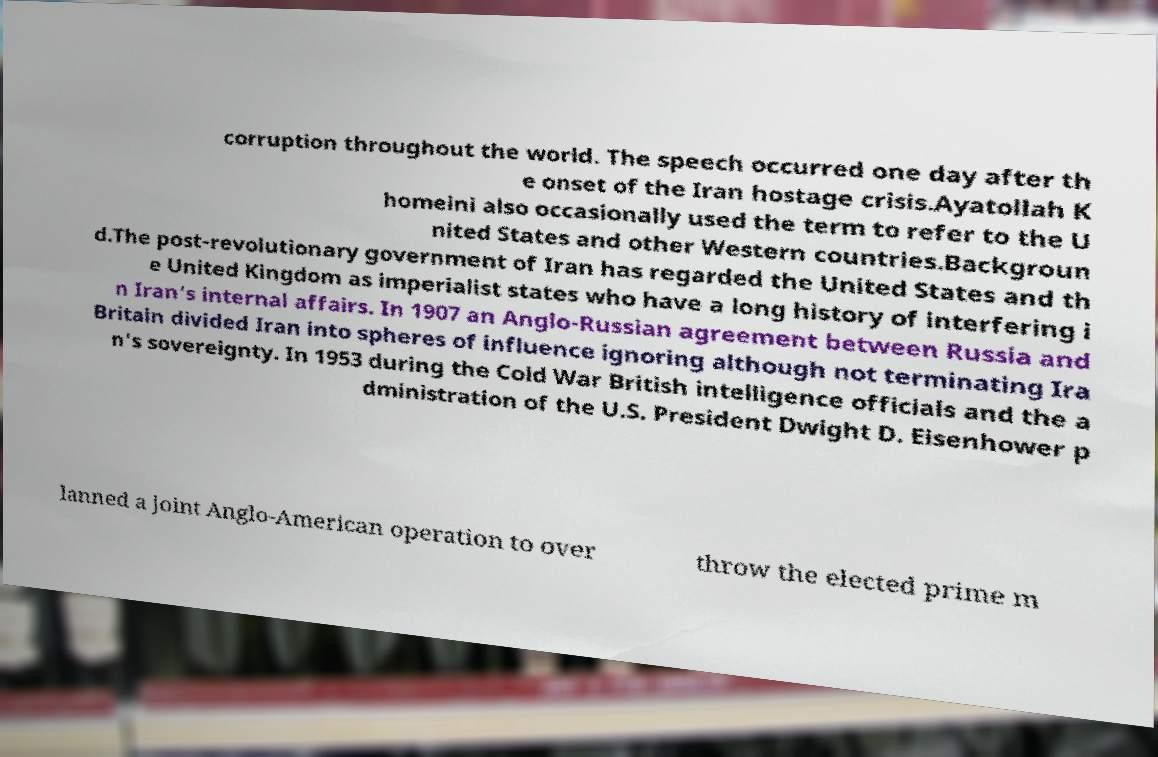Can you read and provide the text displayed in the image?This photo seems to have some interesting text. Can you extract and type it out for me? corruption throughout the world. The speech occurred one day after th e onset of the Iran hostage crisis.Ayatollah K homeini also occasionally used the term to refer to the U nited States and other Western countries.Backgroun d.The post-revolutionary government of Iran has regarded the United States and th e United Kingdom as imperialist states who have a long history of interfering i n Iran's internal affairs. In 1907 an Anglo-Russian agreement between Russia and Britain divided Iran into spheres of influence ignoring although not terminating Ira n's sovereignty. In 1953 during the Cold War British intelligence officials and the a dministration of the U.S. President Dwight D. Eisenhower p lanned a joint Anglo-American operation to over throw the elected prime m 